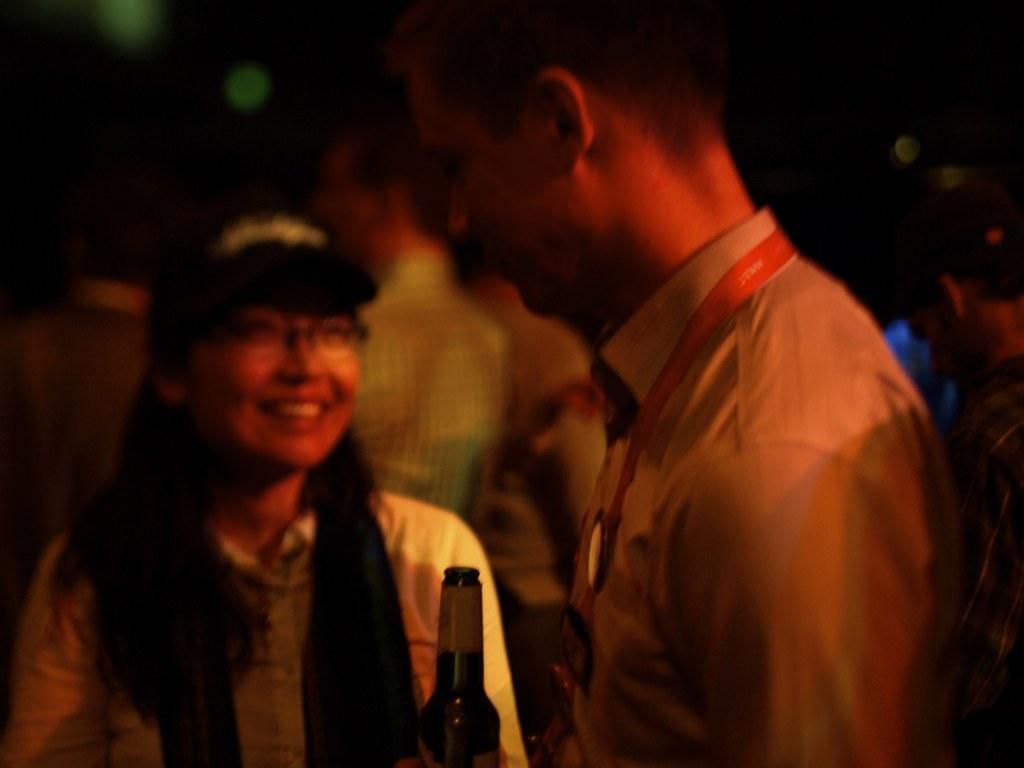How would you summarize this image in a sentence or two? In the center we can see two persons were standing. The woman she is smiling and the man he is holding beer bottle. And back we can see few persons were standing. 